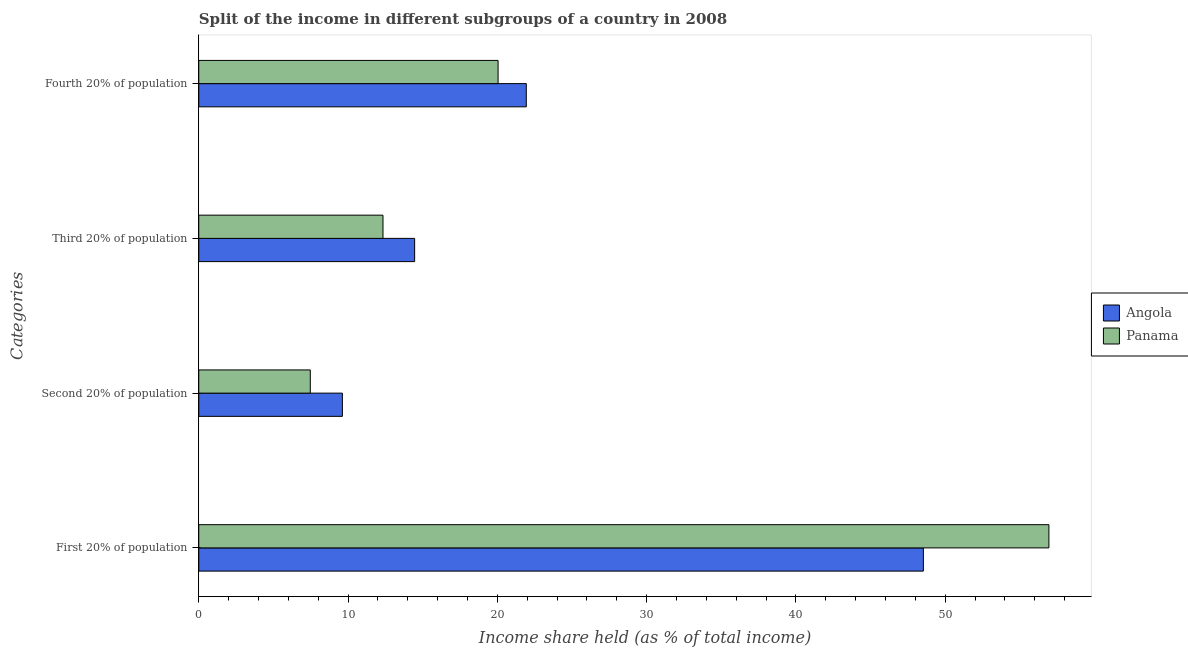Are the number of bars on each tick of the Y-axis equal?
Your answer should be very brief. Yes. How many bars are there on the 3rd tick from the bottom?
Give a very brief answer. 2. What is the label of the 2nd group of bars from the top?
Provide a short and direct response. Third 20% of population. What is the share of the income held by second 20% of the population in Panama?
Provide a succinct answer. 7.47. Across all countries, what is the maximum share of the income held by first 20% of the population?
Provide a short and direct response. 56.95. Across all countries, what is the minimum share of the income held by fourth 20% of the population?
Your answer should be very brief. 20.05. In which country was the share of the income held by second 20% of the population maximum?
Keep it short and to the point. Angola. In which country was the share of the income held by third 20% of the population minimum?
Make the answer very short. Panama. What is the total share of the income held by first 20% of the population in the graph?
Make the answer very short. 105.49. What is the difference between the share of the income held by third 20% of the population in Angola and that in Panama?
Make the answer very short. 2.12. What is the difference between the share of the income held by first 20% of the population in Panama and the share of the income held by second 20% of the population in Angola?
Your answer should be very brief. 47.33. What is the average share of the income held by fourth 20% of the population per country?
Ensure brevity in your answer.  21. What is the difference between the share of the income held by fourth 20% of the population and share of the income held by first 20% of the population in Angola?
Offer a terse response. -26.6. What is the ratio of the share of the income held by fourth 20% of the population in Angola to that in Panama?
Give a very brief answer. 1.09. Is the difference between the share of the income held by third 20% of the population in Angola and Panama greater than the difference between the share of the income held by fourth 20% of the population in Angola and Panama?
Give a very brief answer. Yes. What is the difference between the highest and the second highest share of the income held by third 20% of the population?
Ensure brevity in your answer.  2.12. What is the difference between the highest and the lowest share of the income held by first 20% of the population?
Your answer should be very brief. 8.41. In how many countries, is the share of the income held by third 20% of the population greater than the average share of the income held by third 20% of the population taken over all countries?
Keep it short and to the point. 1. Is the sum of the share of the income held by third 20% of the population in Panama and Angola greater than the maximum share of the income held by first 20% of the population across all countries?
Your answer should be compact. No. Is it the case that in every country, the sum of the share of the income held by second 20% of the population and share of the income held by first 20% of the population is greater than the sum of share of the income held by fourth 20% of the population and share of the income held by third 20% of the population?
Make the answer very short. Yes. What does the 1st bar from the top in Third 20% of population represents?
Give a very brief answer. Panama. What does the 1st bar from the bottom in Fourth 20% of population represents?
Offer a terse response. Angola. Are all the bars in the graph horizontal?
Provide a short and direct response. Yes. How many countries are there in the graph?
Ensure brevity in your answer.  2. Does the graph contain grids?
Offer a terse response. No. How many legend labels are there?
Keep it short and to the point. 2. How are the legend labels stacked?
Ensure brevity in your answer.  Vertical. What is the title of the graph?
Your answer should be compact. Split of the income in different subgroups of a country in 2008. What is the label or title of the X-axis?
Provide a succinct answer. Income share held (as % of total income). What is the label or title of the Y-axis?
Offer a terse response. Categories. What is the Income share held (as % of total income) of Angola in First 20% of population?
Keep it short and to the point. 48.54. What is the Income share held (as % of total income) of Panama in First 20% of population?
Make the answer very short. 56.95. What is the Income share held (as % of total income) in Angola in Second 20% of population?
Give a very brief answer. 9.62. What is the Income share held (as % of total income) of Panama in Second 20% of population?
Your response must be concise. 7.47. What is the Income share held (as % of total income) of Angola in Third 20% of population?
Make the answer very short. 14.46. What is the Income share held (as % of total income) in Panama in Third 20% of population?
Give a very brief answer. 12.34. What is the Income share held (as % of total income) in Angola in Fourth 20% of population?
Ensure brevity in your answer.  21.94. What is the Income share held (as % of total income) in Panama in Fourth 20% of population?
Offer a terse response. 20.05. Across all Categories, what is the maximum Income share held (as % of total income) in Angola?
Provide a succinct answer. 48.54. Across all Categories, what is the maximum Income share held (as % of total income) in Panama?
Your answer should be compact. 56.95. Across all Categories, what is the minimum Income share held (as % of total income) in Angola?
Your answer should be compact. 9.62. Across all Categories, what is the minimum Income share held (as % of total income) in Panama?
Give a very brief answer. 7.47. What is the total Income share held (as % of total income) of Angola in the graph?
Provide a succinct answer. 94.56. What is the total Income share held (as % of total income) in Panama in the graph?
Your response must be concise. 96.81. What is the difference between the Income share held (as % of total income) of Angola in First 20% of population and that in Second 20% of population?
Keep it short and to the point. 38.92. What is the difference between the Income share held (as % of total income) in Panama in First 20% of population and that in Second 20% of population?
Ensure brevity in your answer.  49.48. What is the difference between the Income share held (as % of total income) in Angola in First 20% of population and that in Third 20% of population?
Make the answer very short. 34.08. What is the difference between the Income share held (as % of total income) in Panama in First 20% of population and that in Third 20% of population?
Your answer should be compact. 44.61. What is the difference between the Income share held (as % of total income) in Angola in First 20% of population and that in Fourth 20% of population?
Provide a succinct answer. 26.6. What is the difference between the Income share held (as % of total income) of Panama in First 20% of population and that in Fourth 20% of population?
Offer a very short reply. 36.9. What is the difference between the Income share held (as % of total income) of Angola in Second 20% of population and that in Third 20% of population?
Offer a very short reply. -4.84. What is the difference between the Income share held (as % of total income) in Panama in Second 20% of population and that in Third 20% of population?
Make the answer very short. -4.87. What is the difference between the Income share held (as % of total income) in Angola in Second 20% of population and that in Fourth 20% of population?
Provide a succinct answer. -12.32. What is the difference between the Income share held (as % of total income) in Panama in Second 20% of population and that in Fourth 20% of population?
Provide a short and direct response. -12.58. What is the difference between the Income share held (as % of total income) in Angola in Third 20% of population and that in Fourth 20% of population?
Your answer should be compact. -7.48. What is the difference between the Income share held (as % of total income) of Panama in Third 20% of population and that in Fourth 20% of population?
Your answer should be very brief. -7.71. What is the difference between the Income share held (as % of total income) in Angola in First 20% of population and the Income share held (as % of total income) in Panama in Second 20% of population?
Give a very brief answer. 41.07. What is the difference between the Income share held (as % of total income) of Angola in First 20% of population and the Income share held (as % of total income) of Panama in Third 20% of population?
Ensure brevity in your answer.  36.2. What is the difference between the Income share held (as % of total income) in Angola in First 20% of population and the Income share held (as % of total income) in Panama in Fourth 20% of population?
Your answer should be very brief. 28.49. What is the difference between the Income share held (as % of total income) in Angola in Second 20% of population and the Income share held (as % of total income) in Panama in Third 20% of population?
Your answer should be compact. -2.72. What is the difference between the Income share held (as % of total income) in Angola in Second 20% of population and the Income share held (as % of total income) in Panama in Fourth 20% of population?
Offer a terse response. -10.43. What is the difference between the Income share held (as % of total income) in Angola in Third 20% of population and the Income share held (as % of total income) in Panama in Fourth 20% of population?
Your answer should be very brief. -5.59. What is the average Income share held (as % of total income) of Angola per Categories?
Offer a very short reply. 23.64. What is the average Income share held (as % of total income) of Panama per Categories?
Provide a succinct answer. 24.2. What is the difference between the Income share held (as % of total income) in Angola and Income share held (as % of total income) in Panama in First 20% of population?
Give a very brief answer. -8.41. What is the difference between the Income share held (as % of total income) in Angola and Income share held (as % of total income) in Panama in Second 20% of population?
Your answer should be very brief. 2.15. What is the difference between the Income share held (as % of total income) of Angola and Income share held (as % of total income) of Panama in Third 20% of population?
Give a very brief answer. 2.12. What is the difference between the Income share held (as % of total income) in Angola and Income share held (as % of total income) in Panama in Fourth 20% of population?
Offer a very short reply. 1.89. What is the ratio of the Income share held (as % of total income) in Angola in First 20% of population to that in Second 20% of population?
Your answer should be compact. 5.05. What is the ratio of the Income share held (as % of total income) of Panama in First 20% of population to that in Second 20% of population?
Make the answer very short. 7.62. What is the ratio of the Income share held (as % of total income) in Angola in First 20% of population to that in Third 20% of population?
Your answer should be compact. 3.36. What is the ratio of the Income share held (as % of total income) of Panama in First 20% of population to that in Third 20% of population?
Provide a short and direct response. 4.62. What is the ratio of the Income share held (as % of total income) of Angola in First 20% of population to that in Fourth 20% of population?
Offer a very short reply. 2.21. What is the ratio of the Income share held (as % of total income) of Panama in First 20% of population to that in Fourth 20% of population?
Keep it short and to the point. 2.84. What is the ratio of the Income share held (as % of total income) in Angola in Second 20% of population to that in Third 20% of population?
Offer a terse response. 0.67. What is the ratio of the Income share held (as % of total income) in Panama in Second 20% of population to that in Third 20% of population?
Offer a very short reply. 0.61. What is the ratio of the Income share held (as % of total income) of Angola in Second 20% of population to that in Fourth 20% of population?
Give a very brief answer. 0.44. What is the ratio of the Income share held (as % of total income) in Panama in Second 20% of population to that in Fourth 20% of population?
Your answer should be very brief. 0.37. What is the ratio of the Income share held (as % of total income) in Angola in Third 20% of population to that in Fourth 20% of population?
Make the answer very short. 0.66. What is the ratio of the Income share held (as % of total income) in Panama in Third 20% of population to that in Fourth 20% of population?
Offer a very short reply. 0.62. What is the difference between the highest and the second highest Income share held (as % of total income) in Angola?
Your response must be concise. 26.6. What is the difference between the highest and the second highest Income share held (as % of total income) in Panama?
Offer a terse response. 36.9. What is the difference between the highest and the lowest Income share held (as % of total income) in Angola?
Offer a very short reply. 38.92. What is the difference between the highest and the lowest Income share held (as % of total income) in Panama?
Offer a very short reply. 49.48. 